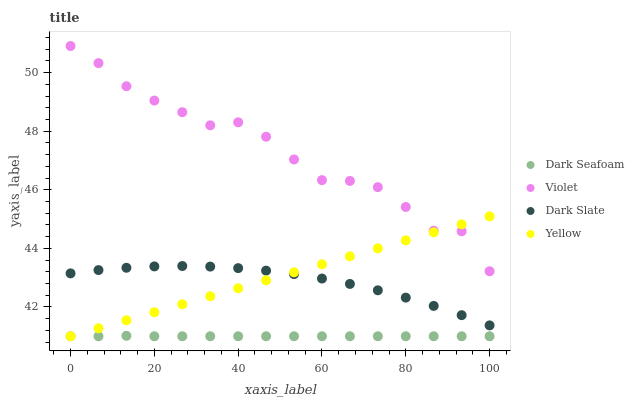Does Dark Seafoam have the minimum area under the curve?
Answer yes or no. Yes. Does Violet have the maximum area under the curve?
Answer yes or no. Yes. Does Yellow have the minimum area under the curve?
Answer yes or no. No. Does Yellow have the maximum area under the curve?
Answer yes or no. No. Is Yellow the smoothest?
Answer yes or no. Yes. Is Violet the roughest?
Answer yes or no. Yes. Is Dark Seafoam the smoothest?
Answer yes or no. No. Is Dark Seafoam the roughest?
Answer yes or no. No. Does Dark Seafoam have the lowest value?
Answer yes or no. Yes. Does Violet have the lowest value?
Answer yes or no. No. Does Violet have the highest value?
Answer yes or no. Yes. Does Yellow have the highest value?
Answer yes or no. No. Is Dark Slate less than Violet?
Answer yes or no. Yes. Is Violet greater than Dark Slate?
Answer yes or no. Yes. Does Yellow intersect Violet?
Answer yes or no. Yes. Is Yellow less than Violet?
Answer yes or no. No. Is Yellow greater than Violet?
Answer yes or no. No. Does Dark Slate intersect Violet?
Answer yes or no. No. 